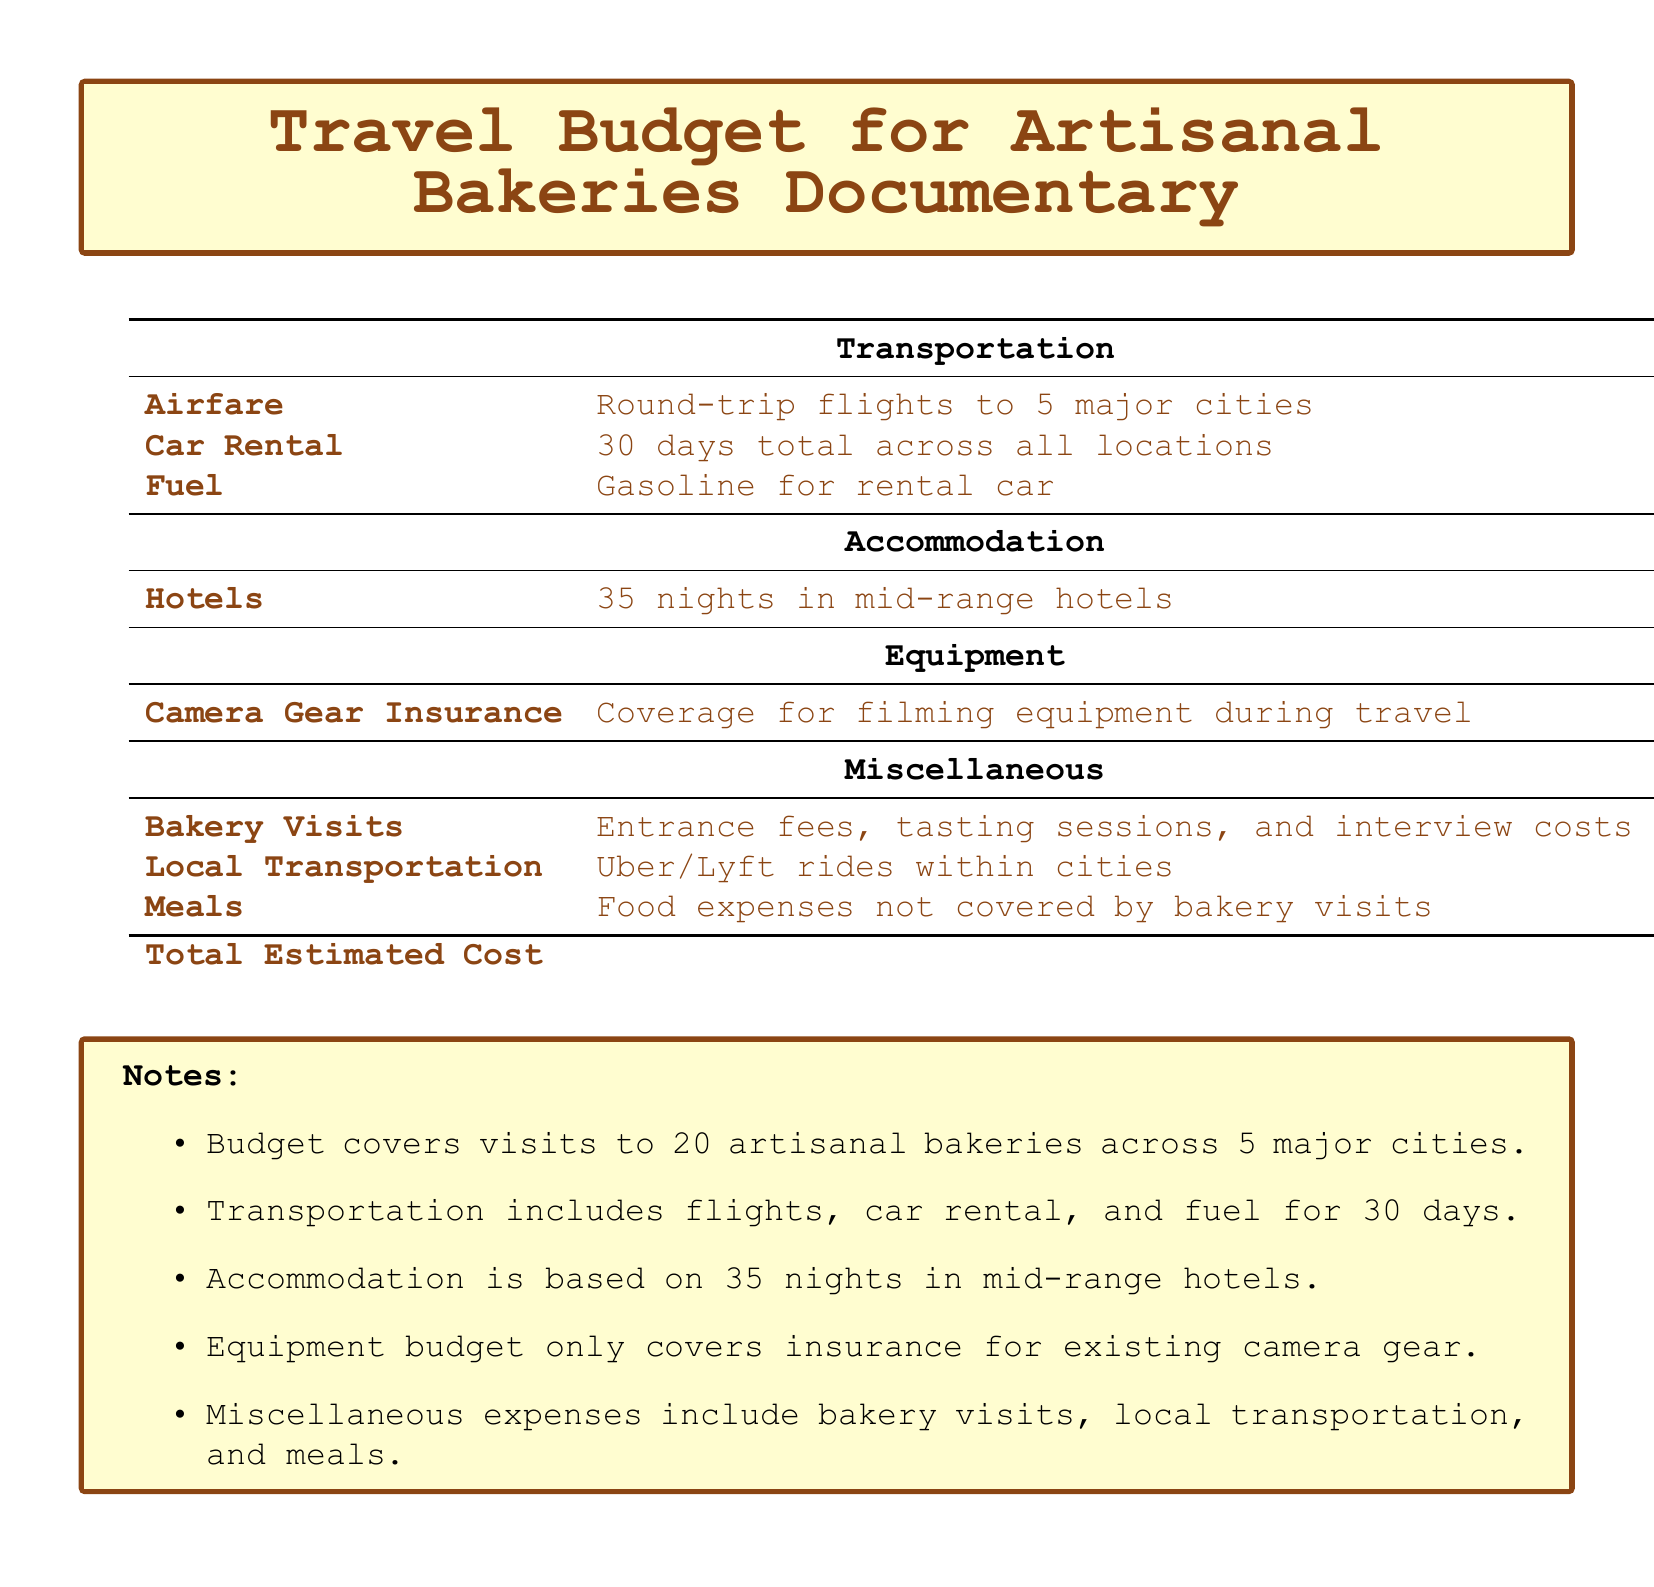What is the total estimated cost? The total estimated cost is explicitly stated at the bottom of the document.
Answer: $12,200 How many bakeries will be visited? The document specifies that the budget covers visits to 20 artisanal bakeries.
Answer: 20 What is the accommodation budget for hotels? The budget table lists accommodation costs specifically for hotels.
Answer: $4,200 How many nights of accommodation are included? The document mentions that the budget accounts for 35 nights in mid-range hotels.
Answer: 35 What is the cost for local transportation? The miscellaneous section specifies the budget for Uber/Lyft rides within cities.
Answer: $400 What is the budget for meals? The meals budget is included in the miscellaneous expenses listed in the document.
Answer: $1,500 What is the total cost for airfare? The transportation section details the cost for round-trip flights.
Answer: $2,500 How many days will the car rental cover? The document states that the car rental expense covers a total of 30 days across all locations.
Answer: 30 What does the equipment budget cover? The document specifies that the equipment budget solely covers insurance for existing camera gear.
Answer: Insurance 